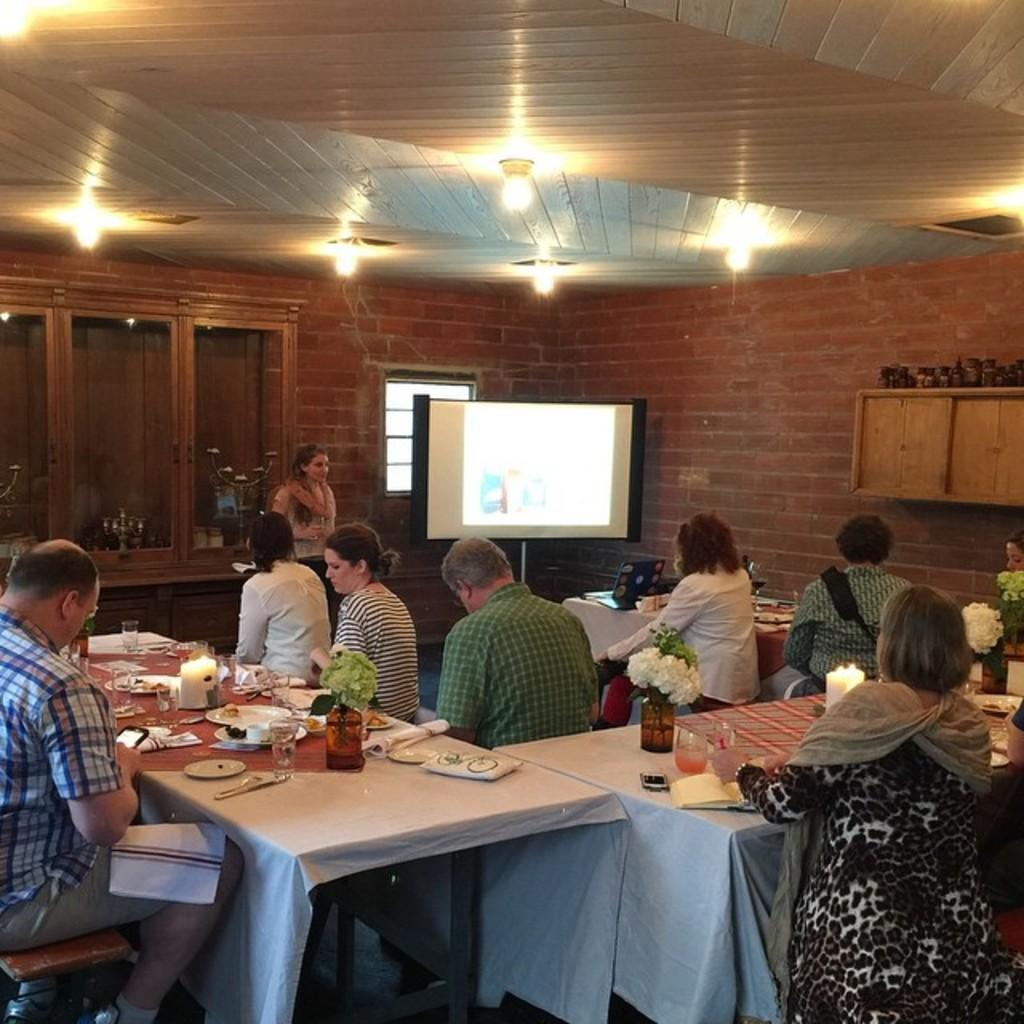What type of structure is visible in the image? There is a brick wall in the image. What can be seen on the wall in the image? There is a screen on the wall in the image. What are the people in the image doing? The people in the image are sitting on chairs. What is on the table in the image? There is a candle, plates, spoons, forks, and glasses on the table in the image. How many bikes are parked next to the brick wall in the image? There are no bikes visible in the image; it only shows a brick wall, a screen, people sitting on chairs, and a table with various items on it. What suggestion is being made by the people sitting on chairs in the image? The image does not provide any information about a suggestion being made by the people sitting on chairs. 